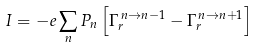Convert formula to latex. <formula><loc_0><loc_0><loc_500><loc_500>I = - e \sum _ { n } P _ { n } \left [ \Gamma _ { r } ^ { \, n \to n - 1 } - \Gamma _ { r } ^ { \, n \to n + 1 } \right ]</formula> 